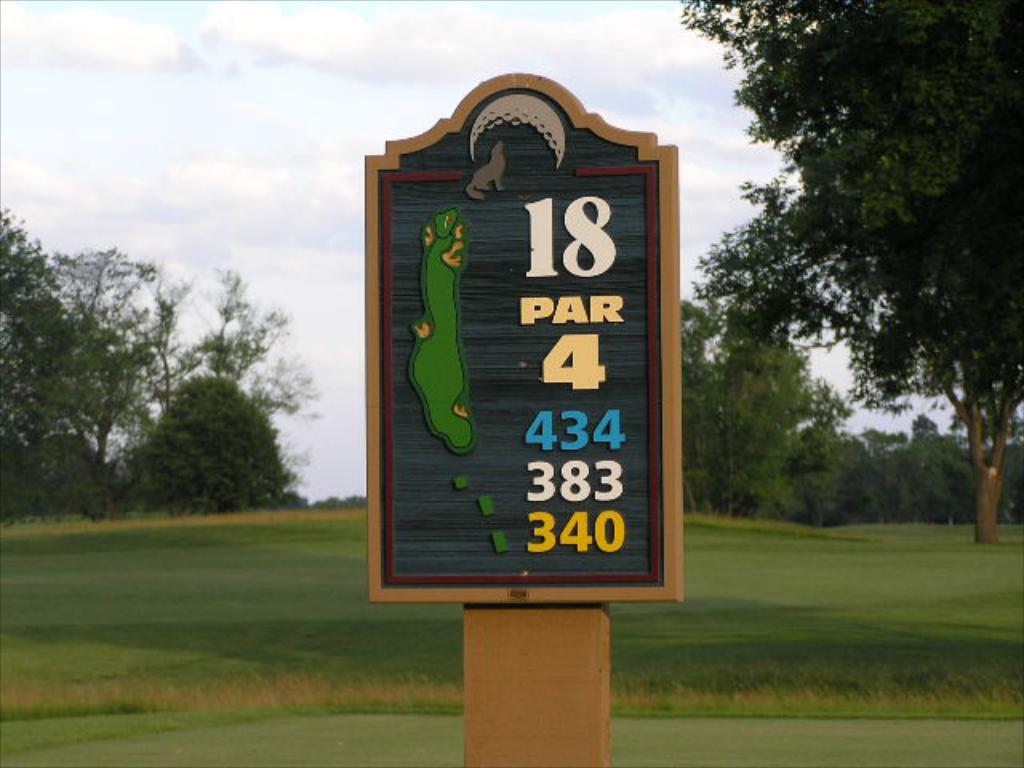How many holes is the course?
Your answer should be very brief. 18. 